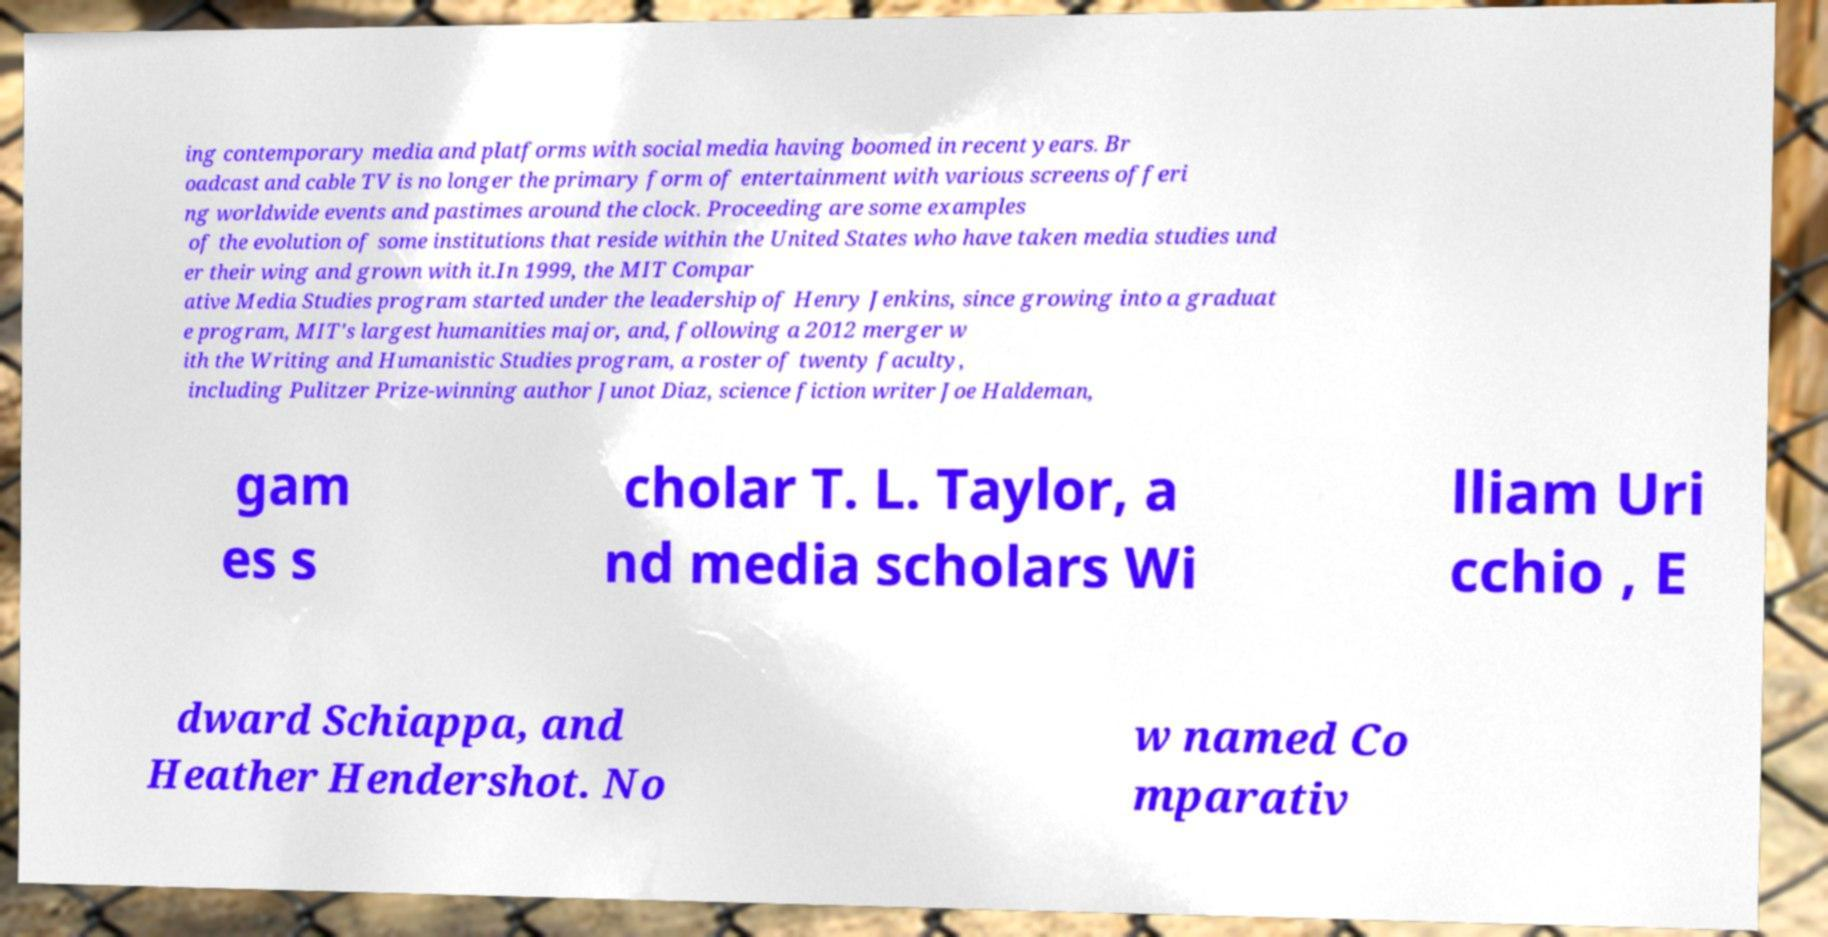For documentation purposes, I need the text within this image transcribed. Could you provide that? ing contemporary media and platforms with social media having boomed in recent years. Br oadcast and cable TV is no longer the primary form of entertainment with various screens offeri ng worldwide events and pastimes around the clock. Proceeding are some examples of the evolution of some institutions that reside within the United States who have taken media studies und er their wing and grown with it.In 1999, the MIT Compar ative Media Studies program started under the leadership of Henry Jenkins, since growing into a graduat e program, MIT's largest humanities major, and, following a 2012 merger w ith the Writing and Humanistic Studies program, a roster of twenty faculty, including Pulitzer Prize-winning author Junot Diaz, science fiction writer Joe Haldeman, gam es s cholar T. L. Taylor, a nd media scholars Wi lliam Uri cchio , E dward Schiappa, and Heather Hendershot. No w named Co mparativ 